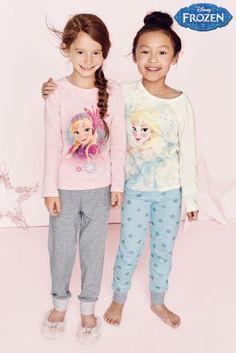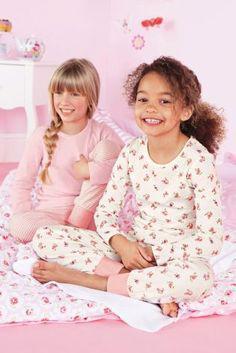The first image is the image on the left, the second image is the image on the right. Analyze the images presented: Is the assertion "There are four people in each set of images." valid? Answer yes or no. Yes. 